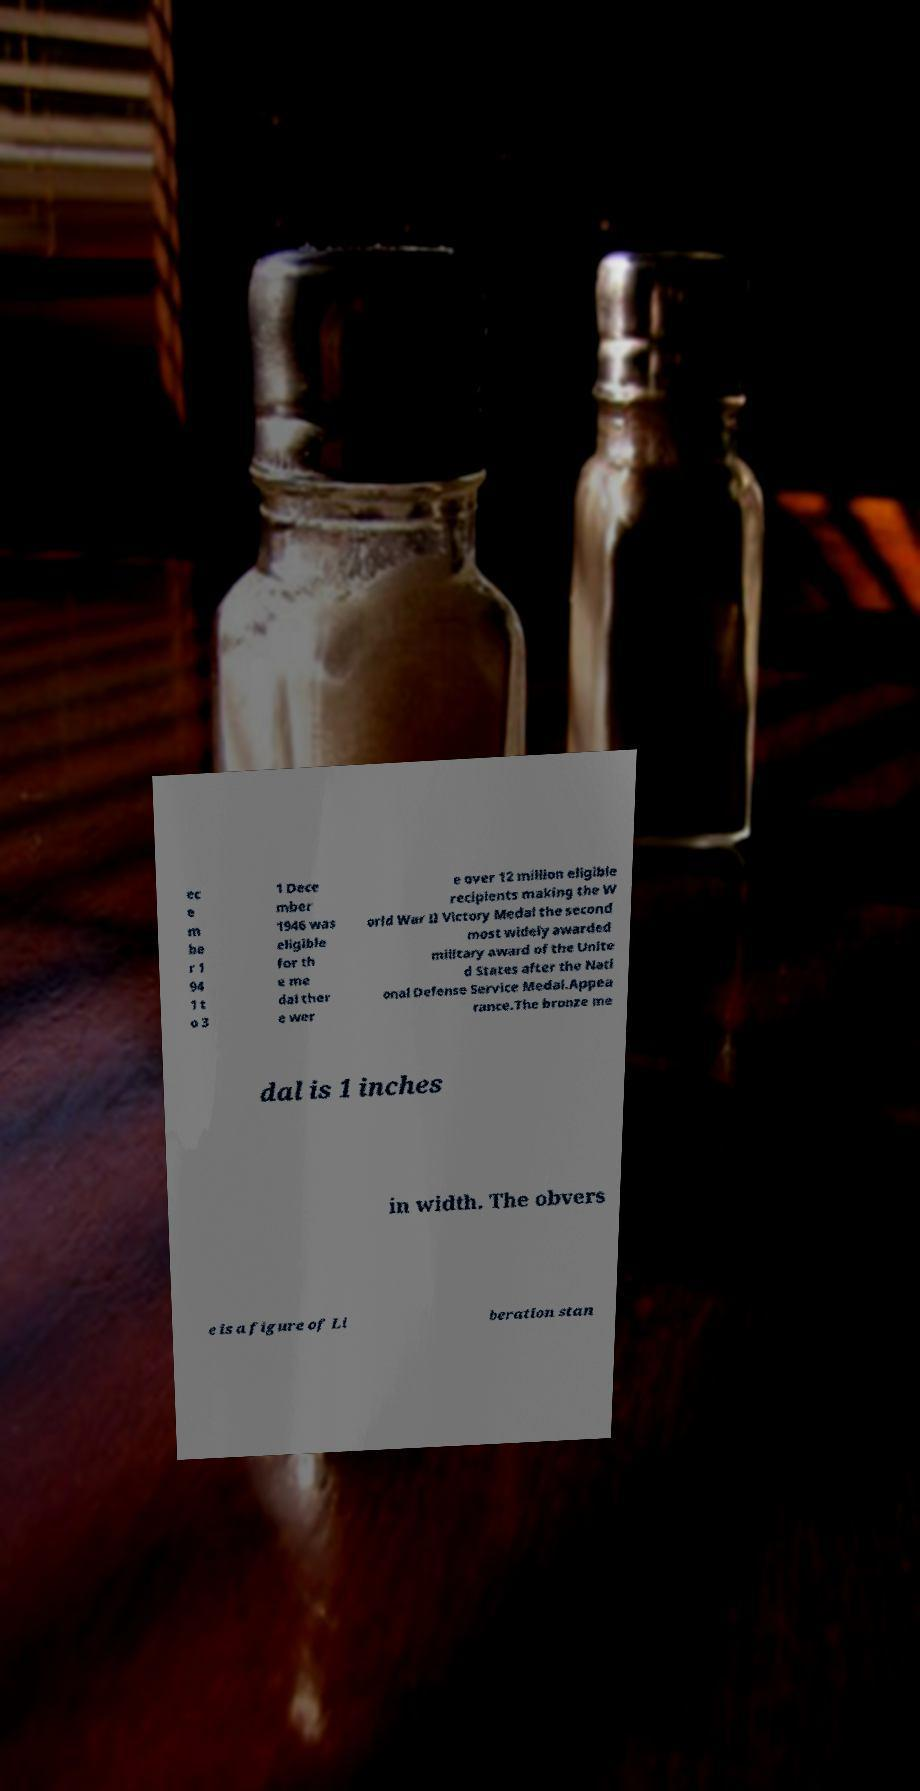Could you assist in decoding the text presented in this image and type it out clearly? ec e m be r 1 94 1 t o 3 1 Dece mber 1946 was eligible for th e me dal ther e wer e over 12 million eligible recipients making the W orld War II Victory Medal the second most widely awarded military award of the Unite d States after the Nati onal Defense Service Medal.Appea rance.The bronze me dal is 1 inches in width. The obvers e is a figure of Li beration stan 